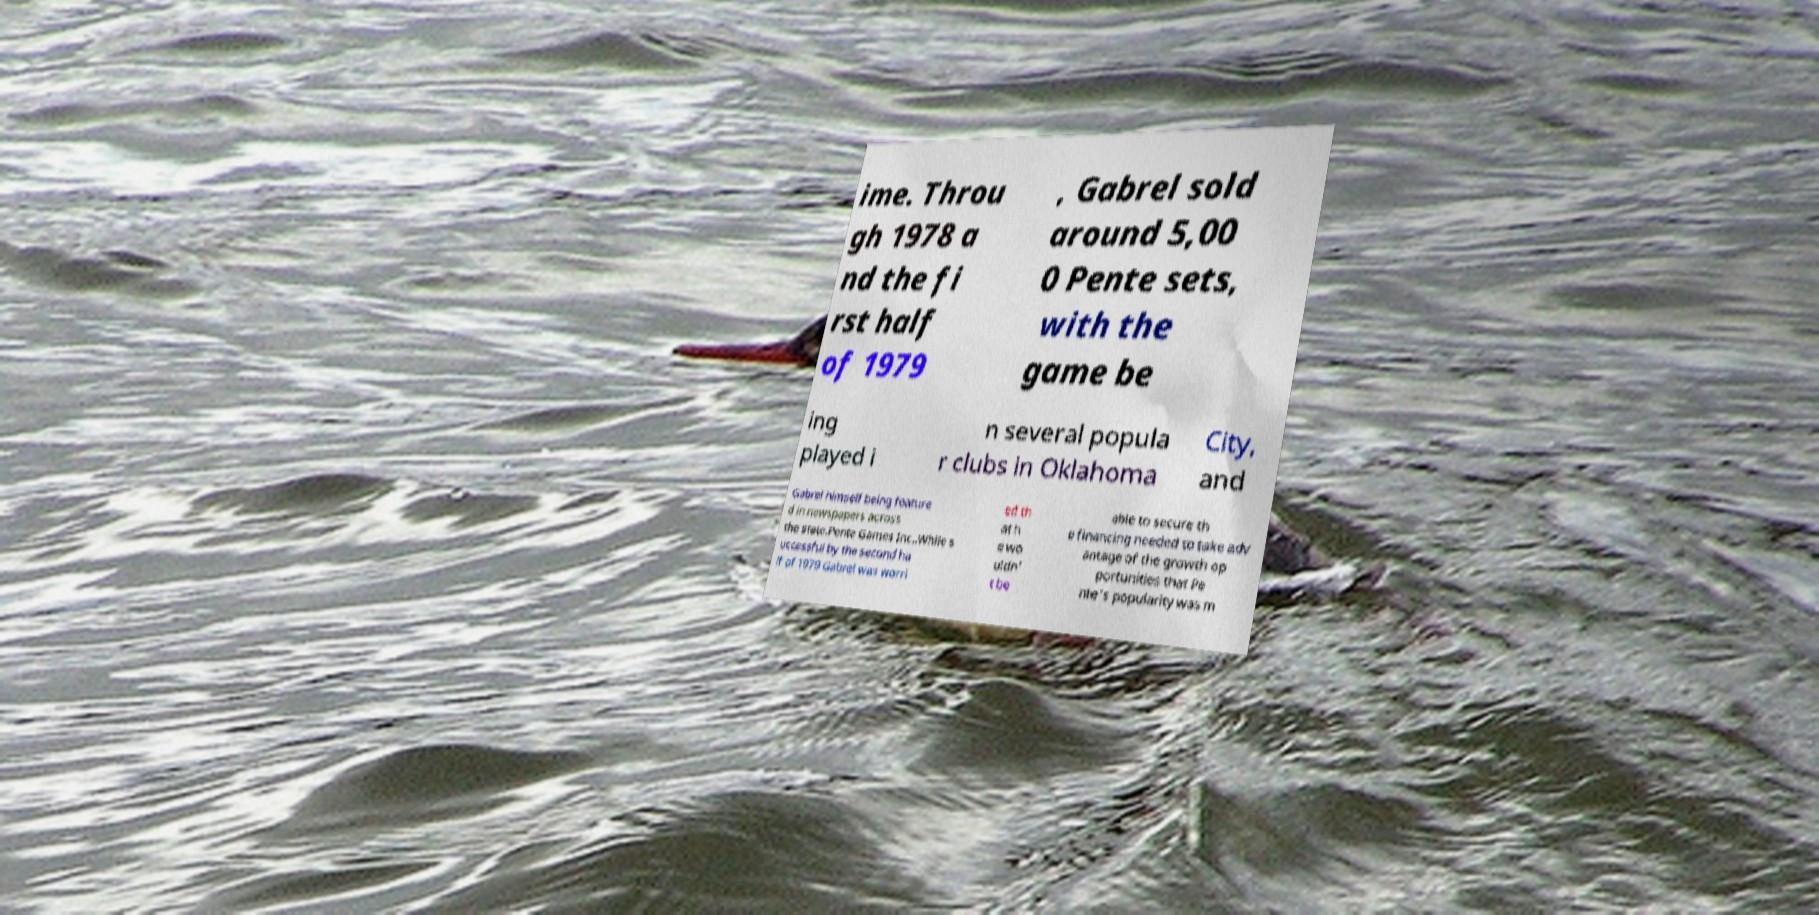Can you read and provide the text displayed in the image?This photo seems to have some interesting text. Can you extract and type it out for me? ime. Throu gh 1978 a nd the fi rst half of 1979 , Gabrel sold around 5,00 0 Pente sets, with the game be ing played i n several popula r clubs in Oklahoma City, and Gabrel himself being feature d in newspapers across the state.Pente Games Inc..While s uccessful by the second ha lf of 1979 Gabrel was worri ed th at h e wo uldn' t be able to secure th e financing needed to take adv antage of the growth op portunities that Pe nte's popularity was m 